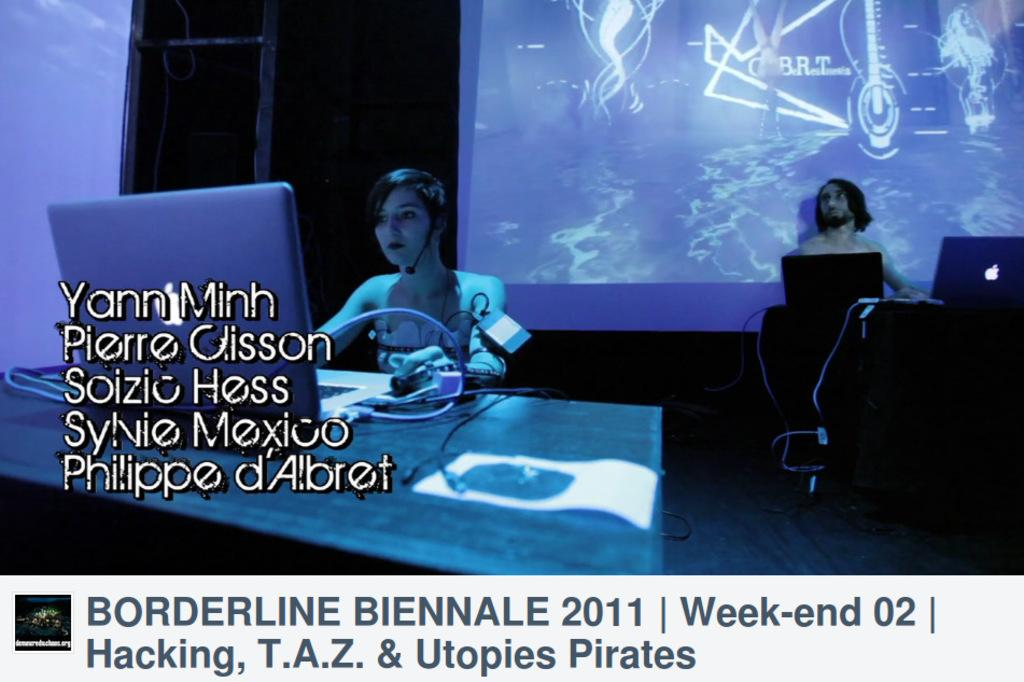What type of picture is in the image? The image contains an animated picture. Who is present in the animated picture? There is a girl and a boy sitting in the animated picture. What can be seen in the image besides the animated picture? Electronic devices, a cable wire, a projected screen, and text are present in the image. What is the name of the owner of the electronic devices in the image? There is no information about the owner of the electronic devices in the image, as the focus is on the animated picture and its contents. 